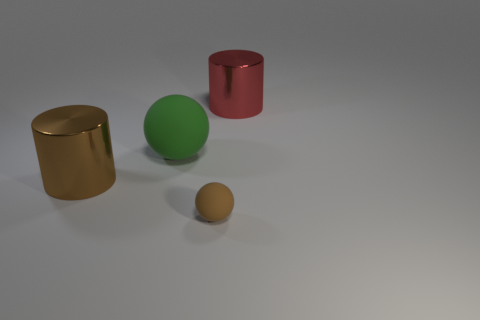Subtract all red cylinders. Subtract all yellow cubes. How many cylinders are left? 1 Add 3 brown metal cylinders. How many objects exist? 7 Add 1 brown balls. How many brown balls exist? 2 Subtract 0 cyan balls. How many objects are left? 4 Subtract all large red metallic objects. Subtract all large matte objects. How many objects are left? 2 Add 1 big red cylinders. How many big red cylinders are left? 2 